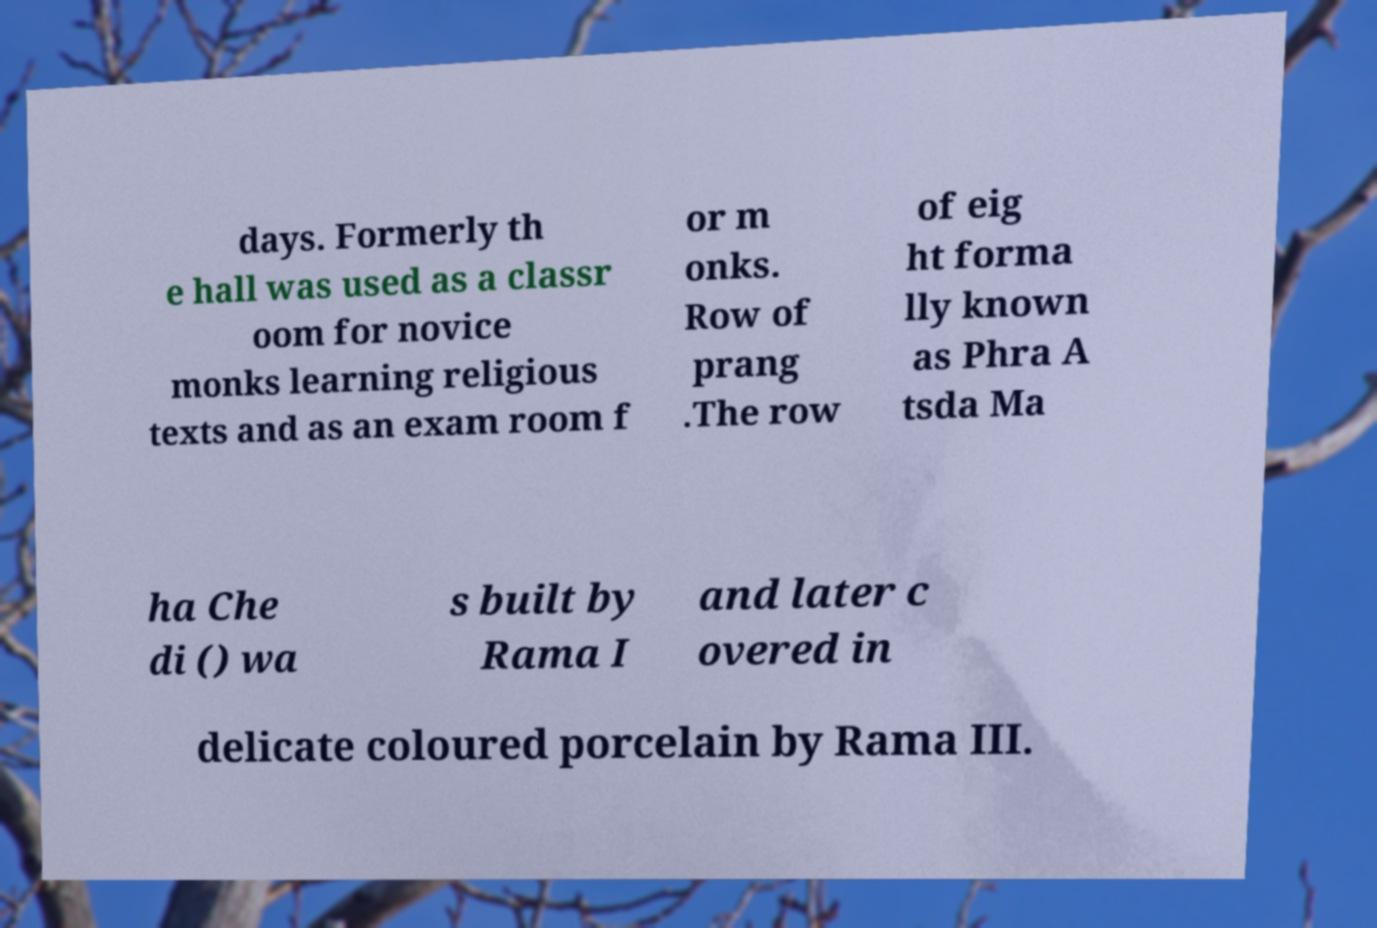Can you accurately transcribe the text from the provided image for me? days. Formerly th e hall was used as a classr oom for novice monks learning religious texts and as an exam room f or m onks. Row of prang .The row of eig ht forma lly known as Phra A tsda Ma ha Che di () wa s built by Rama I and later c overed in delicate coloured porcelain by Rama III. 